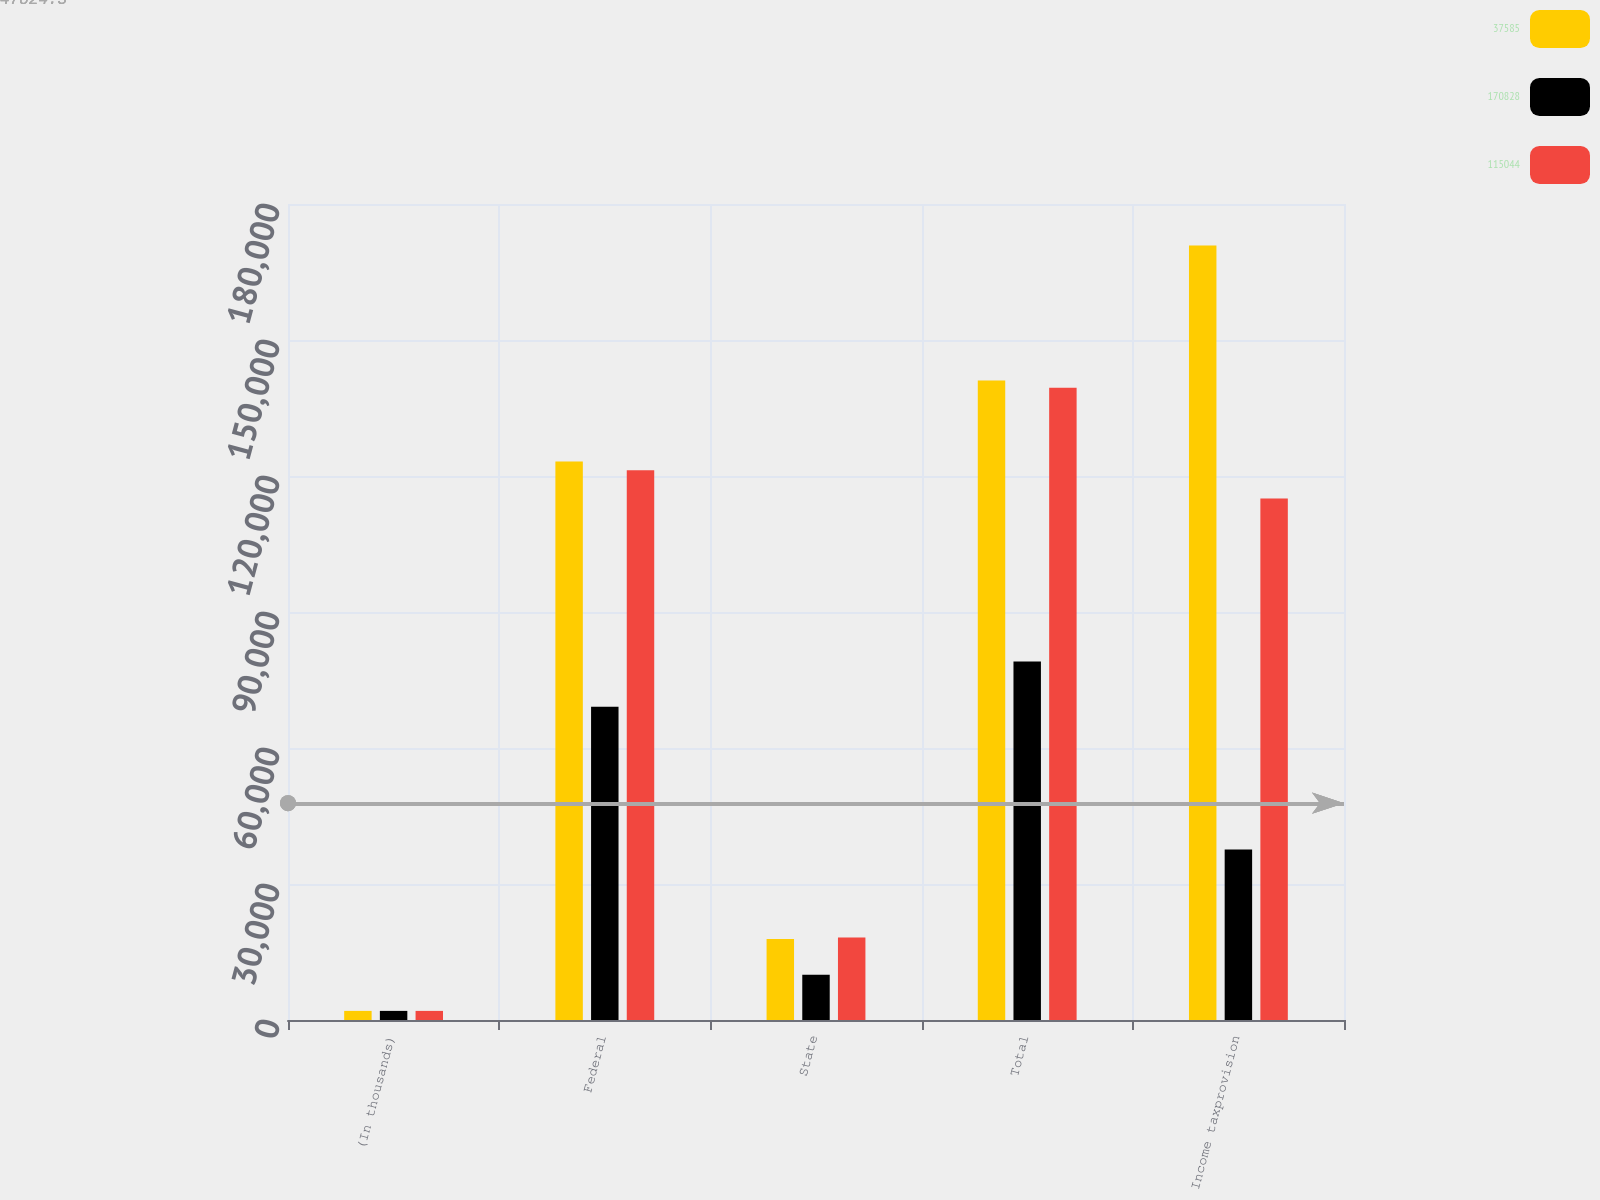<chart> <loc_0><loc_0><loc_500><loc_500><stacked_bar_chart><ecel><fcel>(In thousands)<fcel>Federal<fcel>State<fcel>Total<fcel>Income taxprovision<nl><fcel>37585<fcel>2010<fcel>123215<fcel>17852<fcel>141067<fcel>170828<nl><fcel>170828<fcel>2009<fcel>69095<fcel>9992<fcel>79087<fcel>37585<nl><fcel>115044<fcel>2008<fcel>121274<fcel>18175<fcel>139449<fcel>115044<nl></chart> 